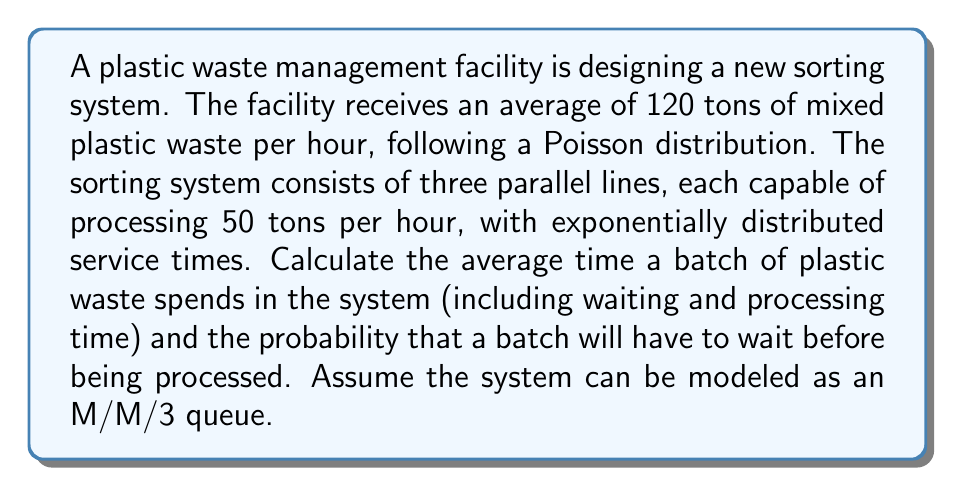Can you solve this math problem? To solve this problem, we'll use queuing theory, specifically the M/M/3 model. Let's break it down step-by-step:

1. Identify the parameters:
   - Arrival rate (λ): 120 tons/hour
   - Service rate per line (μ): 50 tons/hour
   - Number of servers (c): 3

2. Calculate the utilization factor (ρ):
   $$\rho = \frac{\lambda}{c\mu} = \frac{120}{3 \cdot 50} = 0.8$$

3. Calculate P0, the probability of an empty system:
   $$P_0 = \left[\sum_{n=0}^{c-1}\frac{(c\rho)^n}{n!} + \frac{(c\rho)^c}{c!(1-\rho)}\right]^{-1}$$
   $$P_0 = \left[1 + \frac{2.4}{1!} + \frac{2.4^2}{2!} + \frac{2.4^3}{3!(1-0.8)}\right]^{-1} \approx 0.0472$$

4. Calculate Pq, the probability that a batch will have to wait:
   $$P_q = \frac{(c\rho)^c}{c!(1-\rho)}P_0 = \frac{2.4^3}{3!(1-0.8)}0.0472 \approx 0.5660$$

5. Calculate Lq, the average number of batches in the queue:
   $$L_q = \frac{P_q\rho}{1-\rho} = \frac{0.5660 \cdot 0.8}{1-0.8} = 2.2640$$

6. Calculate L, the average number of batches in the system:
   $$L = L_q + c\rho = 2.2640 + 3 \cdot 0.8 = 4.6640$$

7. Calculate W, the average time a batch spends in the system:
   $$W = \frac{L}{\lambda} = \frac{4.6640}{120} = 0.0389\text{ hours} = 2.3333\text{ minutes}$$
Answer: The average time a batch of plastic waste spends in the system is approximately 2.3333 minutes, and the probability that a batch will have to wait before being processed is approximately 0.5660 or 56.60%. 